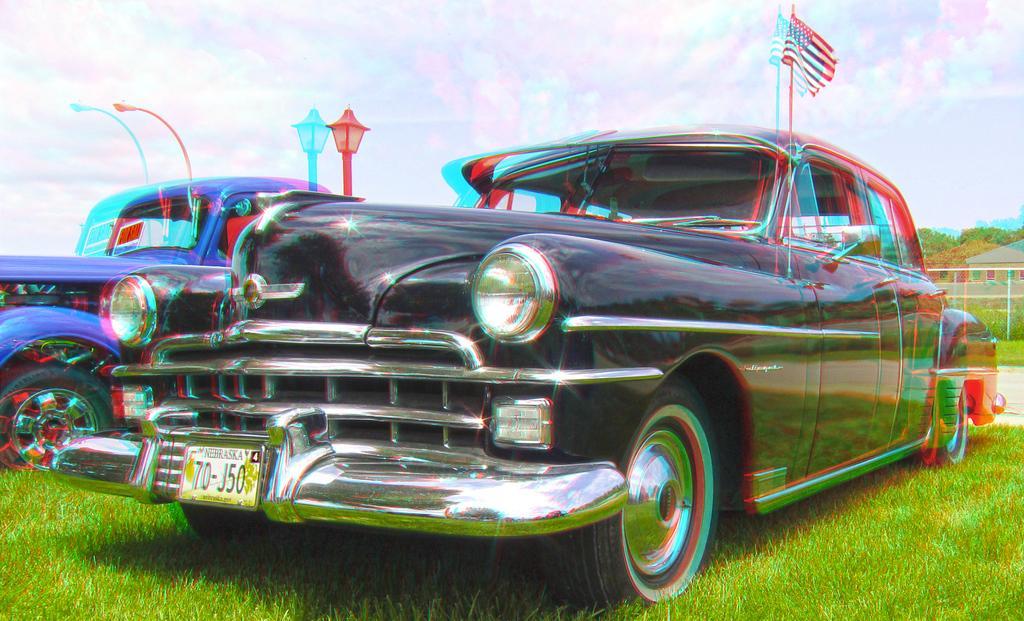In one or two sentences, can you explain what this image depicts? This is a blur image. In this image we can see two cars placed on the ground. We can also see some grass, the flag, a street lamp, street pole, a fence, a group of trees, a house and the sky which looks cloudy. 